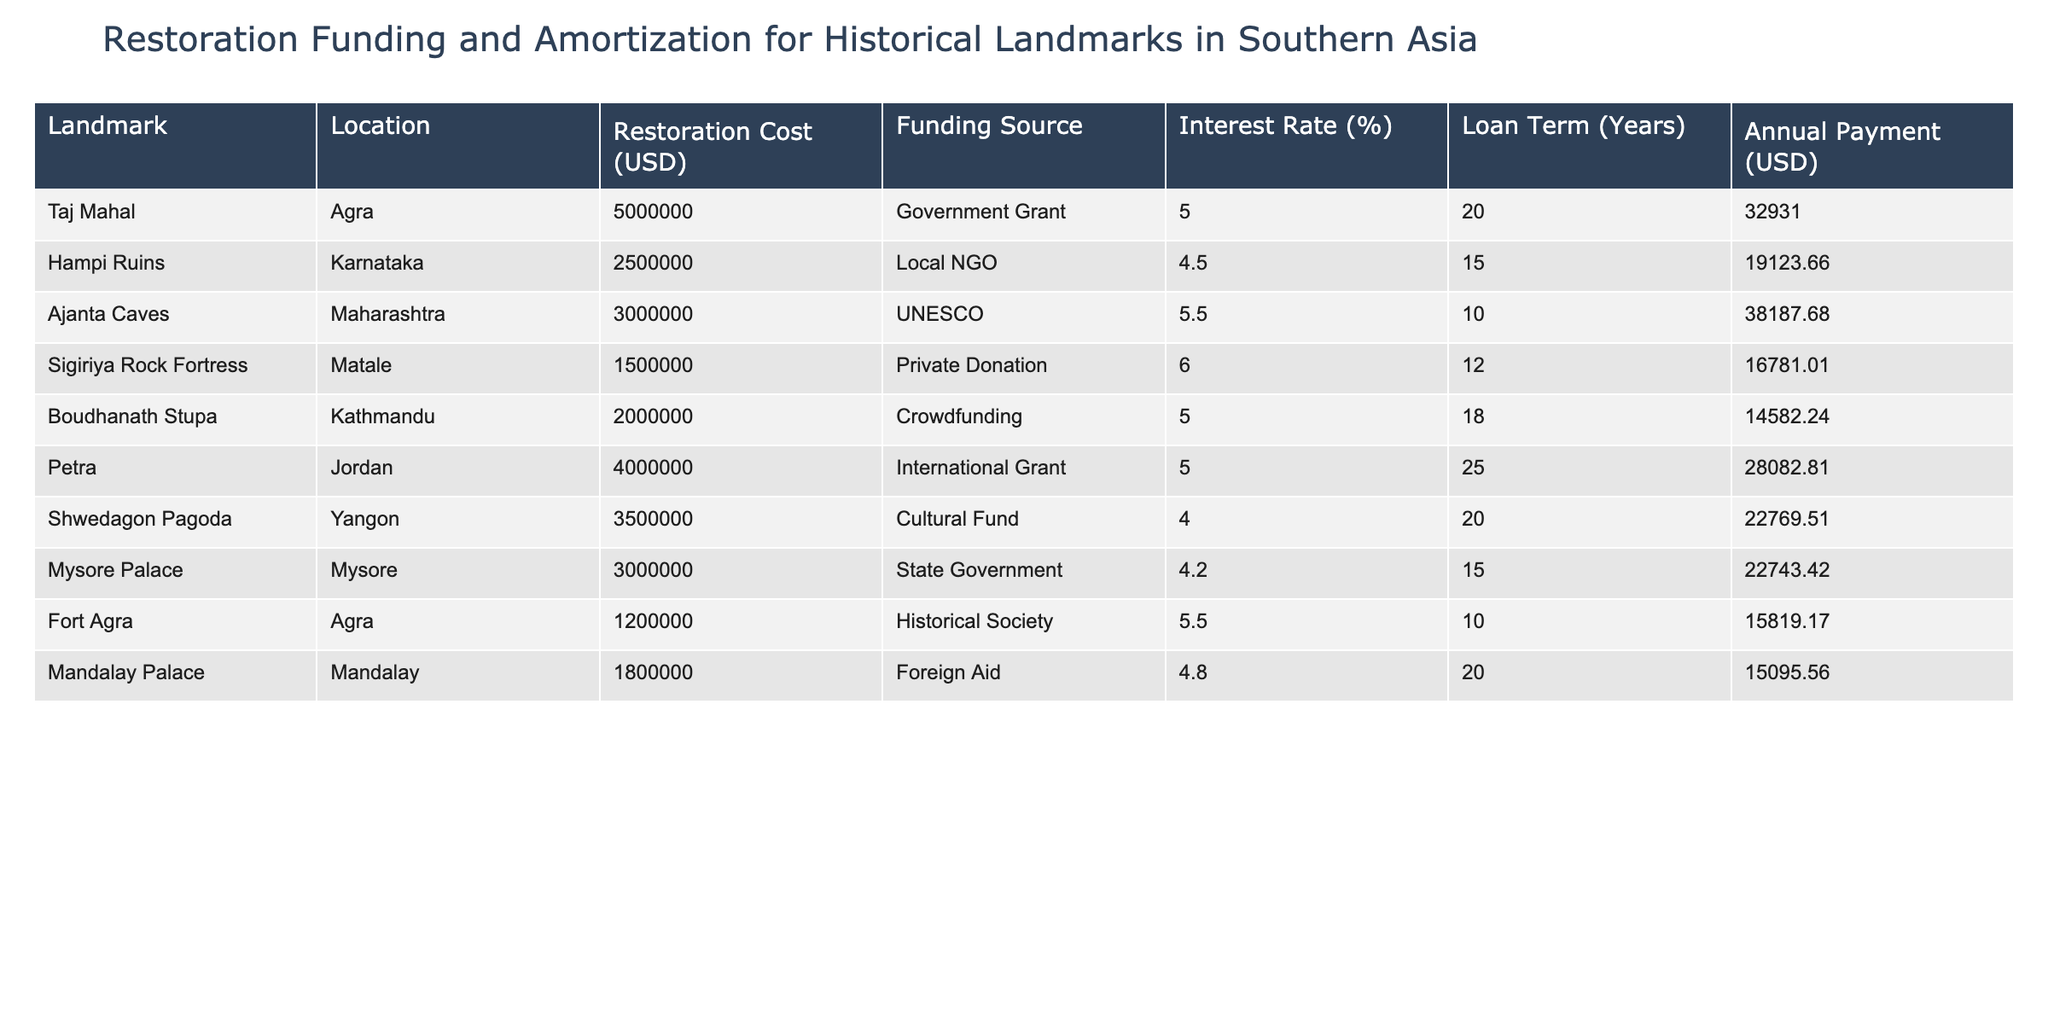What is the restoration cost of the Taj Mahal? The restoration cost is explicitly mentioned in the table under the "Restoration Cost (USD)" column for the Taj Mahal, which is 5,000,000 USD.
Answer: 5000000 Which funding source is used for restoring the Hampi Ruins? Referring to the "Funding Source" column, for the Hampi Ruins, the funding source is listed as "Local NGO."
Answer: Local NGO What is the loan term for the Ajanta Caves restoration? The loan term is found in the "Loan Term (Years)" column, where it states that the Ajanta Caves have a loan term of 10 years.
Answer: 10 What is the total restoration cost of the landmarks located in Agra? To find the total restoration cost, we add the restoration costs of Fort Agra and the Taj Mahal: 5,000,000 + 1,200,000 = 6,200,000 USD.
Answer: 6200000 Is the interest rate for the Shwedagon Pagoda higher than that for the Sigiriya Rock Fortress? Comparing the "Interest Rate (%)" column, the Shwedagon Pagoda has an interest rate of 4%, while the Sigiriya Rock Fortress has an interest rate of 6%. Since 4% is less than 6%, the statement is false.
Answer: No Which landmark has the highest annual payment, and what is its amount? Looking at the "Annual Payment (USD)" column, the Ajanta Caves have the highest annual payment listed at 38,187.68 USD.
Answer: Ajanta Caves, 38187.68 What is the average interest rate of restoration funding for the mentioned landmarks? Summing the interest rates: 5 + 4.5 + 5.5 + 6 + 5 + 4 + 4.2 + 5.5 + 4.8 = 45.5, then dividing by the number of landmarks (9): 45.5 / 9 = 5.06, which rounds to approximately 5.06%.
Answer: 5.06 Does any landmark have a loan term of 25 years, and if so, which one? The "Loan Term (Years)" column shows that the only landmark with a loan term of 25 years is Petra.
Answer: Yes, Petra What is the difference in restoration costs between the Boudhanath Stupa and the Hampi Ruins? The restoration costs for the Boudhanath Stupa is 2,000,000 USD, and for the Hampi Ruins, it is 2,500,000 USD. Thus, the difference is calculated as 2,500,000 - 2,000,000 = 500,000 USD.
Answer: 500000 